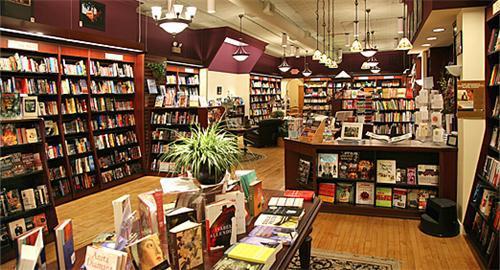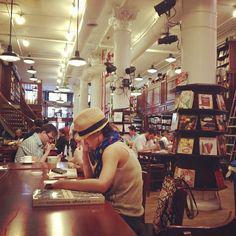The first image is the image on the left, the second image is the image on the right. Evaluate the accuracy of this statement regarding the images: "The right image includes people sitting on opposite sides of a table with bookshelves in the background.". Is it true? Answer yes or no. Yes. The first image is the image on the left, the second image is the image on the right. Assess this claim about the two images: "In at least one image there is an empty bookstore with at least 1 plant.". Correct or not? Answer yes or no. Yes. 